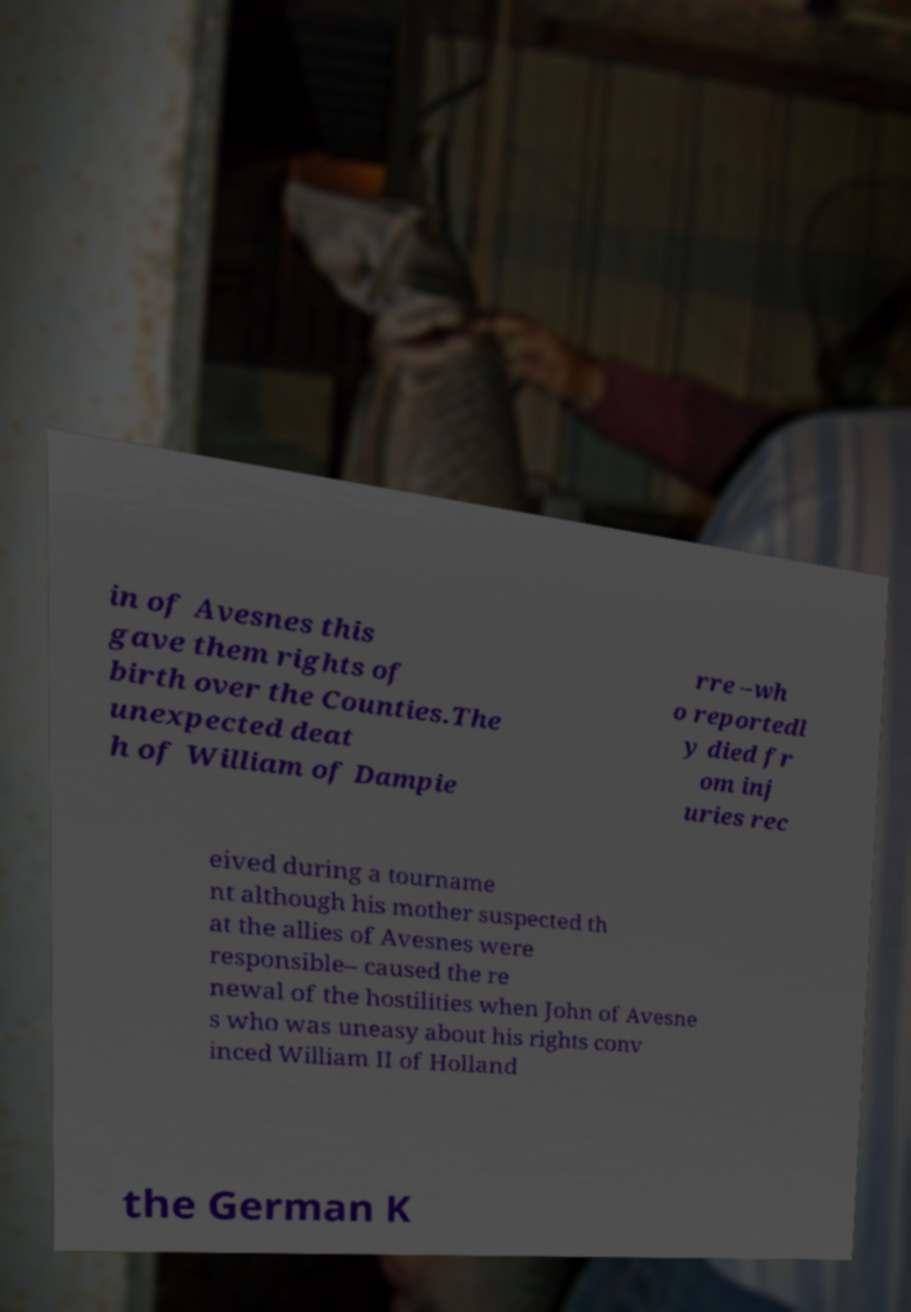For documentation purposes, I need the text within this image transcribed. Could you provide that? in of Avesnes this gave them rights of birth over the Counties.The unexpected deat h of William of Dampie rre –wh o reportedl y died fr om inj uries rec eived during a tourname nt although his mother suspected th at the allies of Avesnes were responsible– caused the re newal of the hostilities when John of Avesne s who was uneasy about his rights conv inced William II of Holland the German K 